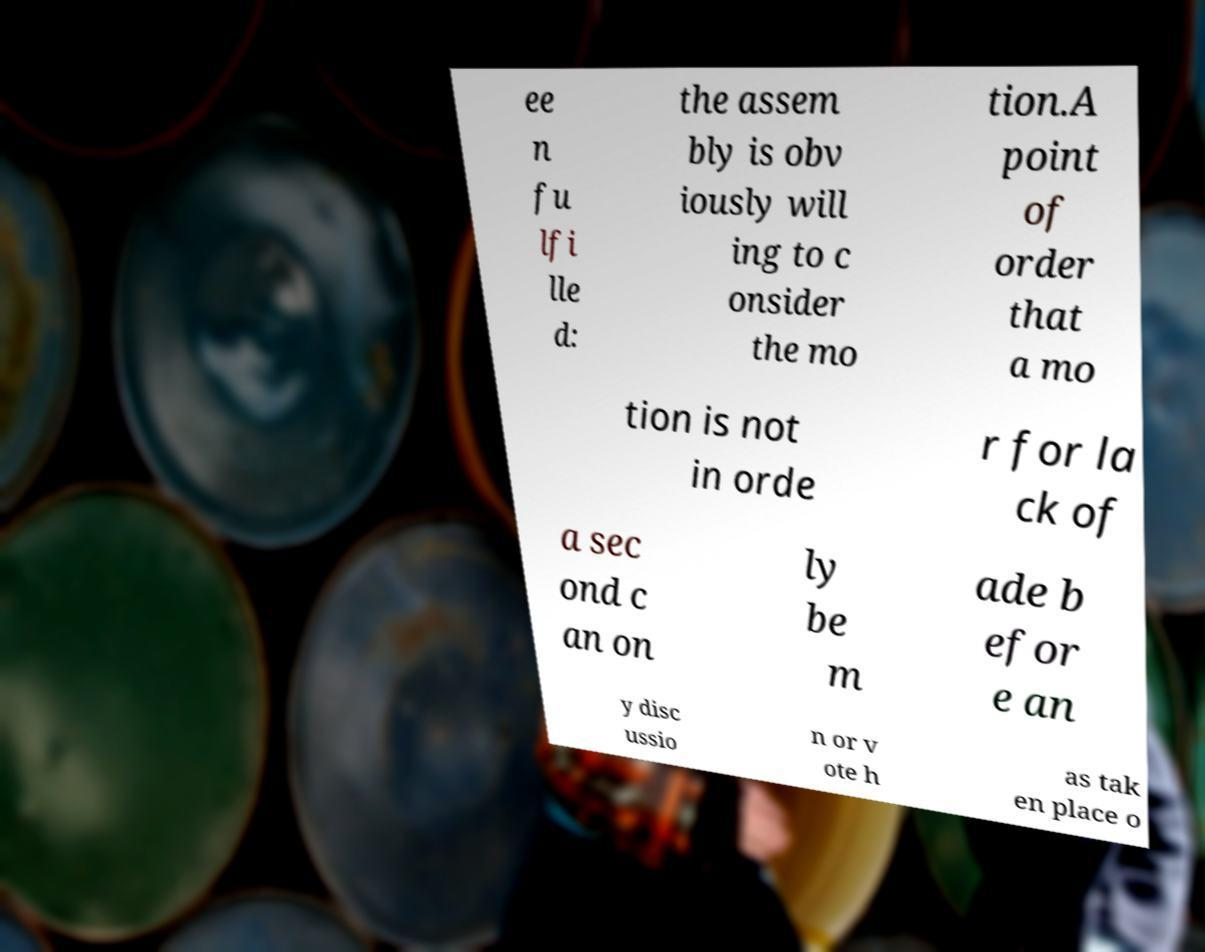Can you accurately transcribe the text from the provided image for me? ee n fu lfi lle d: the assem bly is obv iously will ing to c onsider the mo tion.A point of order that a mo tion is not in orde r for la ck of a sec ond c an on ly be m ade b efor e an y disc ussio n or v ote h as tak en place o 